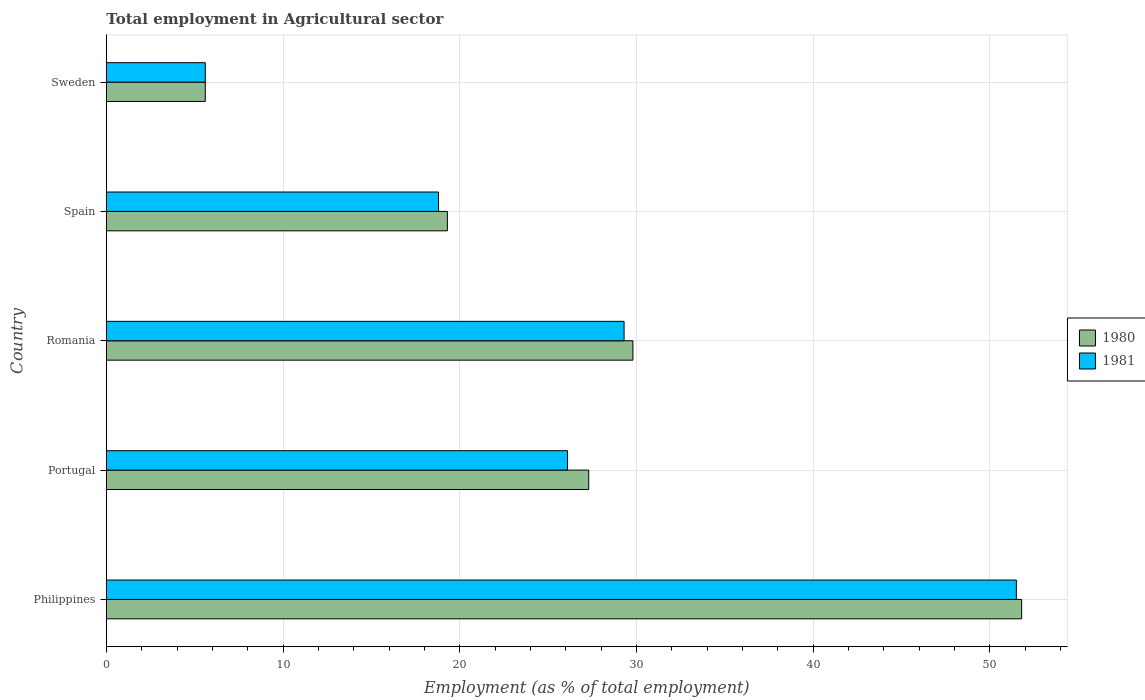How many groups of bars are there?
Give a very brief answer. 5. Are the number of bars on each tick of the Y-axis equal?
Offer a terse response. Yes. How many bars are there on the 3rd tick from the top?
Give a very brief answer. 2. What is the employment in agricultural sector in 1980 in Philippines?
Keep it short and to the point. 51.8. Across all countries, what is the maximum employment in agricultural sector in 1981?
Give a very brief answer. 51.5. Across all countries, what is the minimum employment in agricultural sector in 1981?
Ensure brevity in your answer.  5.6. In which country was the employment in agricultural sector in 1981 maximum?
Provide a succinct answer. Philippines. In which country was the employment in agricultural sector in 1980 minimum?
Your answer should be compact. Sweden. What is the total employment in agricultural sector in 1980 in the graph?
Offer a very short reply. 133.8. What is the difference between the employment in agricultural sector in 1981 in Philippines and that in Romania?
Make the answer very short. 22.2. What is the difference between the employment in agricultural sector in 1981 in Philippines and the employment in agricultural sector in 1980 in Romania?
Make the answer very short. 21.7. What is the average employment in agricultural sector in 1980 per country?
Provide a succinct answer. 26.76. What is the difference between the employment in agricultural sector in 1981 and employment in agricultural sector in 1980 in Sweden?
Your answer should be very brief. 0. What is the ratio of the employment in agricultural sector in 1981 in Portugal to that in Spain?
Your answer should be compact. 1.39. What is the difference between the highest and the second highest employment in agricultural sector in 1980?
Provide a succinct answer. 22. What is the difference between the highest and the lowest employment in agricultural sector in 1981?
Ensure brevity in your answer.  45.9. In how many countries, is the employment in agricultural sector in 1981 greater than the average employment in agricultural sector in 1981 taken over all countries?
Provide a short and direct response. 2. What does the 1st bar from the top in Portugal represents?
Ensure brevity in your answer.  1981. What does the 2nd bar from the bottom in Romania represents?
Provide a succinct answer. 1981. Are all the bars in the graph horizontal?
Your answer should be compact. Yes. What is the difference between two consecutive major ticks on the X-axis?
Your answer should be very brief. 10. Are the values on the major ticks of X-axis written in scientific E-notation?
Provide a short and direct response. No. Does the graph contain any zero values?
Offer a terse response. No. Where does the legend appear in the graph?
Offer a very short reply. Center right. How are the legend labels stacked?
Ensure brevity in your answer.  Vertical. What is the title of the graph?
Ensure brevity in your answer.  Total employment in Agricultural sector. What is the label or title of the X-axis?
Your answer should be very brief. Employment (as % of total employment). What is the Employment (as % of total employment) of 1980 in Philippines?
Your response must be concise. 51.8. What is the Employment (as % of total employment) in 1981 in Philippines?
Your answer should be very brief. 51.5. What is the Employment (as % of total employment) of 1980 in Portugal?
Your answer should be compact. 27.3. What is the Employment (as % of total employment) of 1981 in Portugal?
Provide a succinct answer. 26.1. What is the Employment (as % of total employment) in 1980 in Romania?
Your response must be concise. 29.8. What is the Employment (as % of total employment) of 1981 in Romania?
Offer a very short reply. 29.3. What is the Employment (as % of total employment) of 1980 in Spain?
Keep it short and to the point. 19.3. What is the Employment (as % of total employment) in 1981 in Spain?
Offer a very short reply. 18.8. What is the Employment (as % of total employment) of 1980 in Sweden?
Give a very brief answer. 5.6. What is the Employment (as % of total employment) in 1981 in Sweden?
Provide a short and direct response. 5.6. Across all countries, what is the maximum Employment (as % of total employment) of 1980?
Your response must be concise. 51.8. Across all countries, what is the maximum Employment (as % of total employment) of 1981?
Provide a succinct answer. 51.5. Across all countries, what is the minimum Employment (as % of total employment) of 1980?
Make the answer very short. 5.6. Across all countries, what is the minimum Employment (as % of total employment) of 1981?
Your answer should be very brief. 5.6. What is the total Employment (as % of total employment) of 1980 in the graph?
Give a very brief answer. 133.8. What is the total Employment (as % of total employment) of 1981 in the graph?
Offer a very short reply. 131.3. What is the difference between the Employment (as % of total employment) of 1980 in Philippines and that in Portugal?
Your response must be concise. 24.5. What is the difference between the Employment (as % of total employment) in 1981 in Philippines and that in Portugal?
Your answer should be very brief. 25.4. What is the difference between the Employment (as % of total employment) of 1980 in Philippines and that in Romania?
Your response must be concise. 22. What is the difference between the Employment (as % of total employment) in 1981 in Philippines and that in Romania?
Ensure brevity in your answer.  22.2. What is the difference between the Employment (as % of total employment) in 1980 in Philippines and that in Spain?
Make the answer very short. 32.5. What is the difference between the Employment (as % of total employment) of 1981 in Philippines and that in Spain?
Offer a very short reply. 32.7. What is the difference between the Employment (as % of total employment) of 1980 in Philippines and that in Sweden?
Provide a succinct answer. 46.2. What is the difference between the Employment (as % of total employment) of 1981 in Philippines and that in Sweden?
Provide a short and direct response. 45.9. What is the difference between the Employment (as % of total employment) in 1981 in Portugal and that in Romania?
Offer a very short reply. -3.2. What is the difference between the Employment (as % of total employment) in 1980 in Portugal and that in Sweden?
Keep it short and to the point. 21.7. What is the difference between the Employment (as % of total employment) of 1981 in Portugal and that in Sweden?
Ensure brevity in your answer.  20.5. What is the difference between the Employment (as % of total employment) of 1980 in Romania and that in Spain?
Your answer should be compact. 10.5. What is the difference between the Employment (as % of total employment) in 1981 in Romania and that in Spain?
Give a very brief answer. 10.5. What is the difference between the Employment (as % of total employment) in 1980 in Romania and that in Sweden?
Offer a very short reply. 24.2. What is the difference between the Employment (as % of total employment) in 1981 in Romania and that in Sweden?
Give a very brief answer. 23.7. What is the difference between the Employment (as % of total employment) of 1980 in Philippines and the Employment (as % of total employment) of 1981 in Portugal?
Keep it short and to the point. 25.7. What is the difference between the Employment (as % of total employment) in 1980 in Philippines and the Employment (as % of total employment) in 1981 in Spain?
Your response must be concise. 33. What is the difference between the Employment (as % of total employment) of 1980 in Philippines and the Employment (as % of total employment) of 1981 in Sweden?
Your answer should be very brief. 46.2. What is the difference between the Employment (as % of total employment) of 1980 in Portugal and the Employment (as % of total employment) of 1981 in Spain?
Your answer should be compact. 8.5. What is the difference between the Employment (as % of total employment) in 1980 in Portugal and the Employment (as % of total employment) in 1981 in Sweden?
Ensure brevity in your answer.  21.7. What is the difference between the Employment (as % of total employment) of 1980 in Romania and the Employment (as % of total employment) of 1981 in Sweden?
Ensure brevity in your answer.  24.2. What is the difference between the Employment (as % of total employment) in 1980 in Spain and the Employment (as % of total employment) in 1981 in Sweden?
Provide a succinct answer. 13.7. What is the average Employment (as % of total employment) in 1980 per country?
Offer a terse response. 26.76. What is the average Employment (as % of total employment) in 1981 per country?
Provide a short and direct response. 26.26. What is the difference between the Employment (as % of total employment) in 1980 and Employment (as % of total employment) in 1981 in Philippines?
Provide a short and direct response. 0.3. What is the difference between the Employment (as % of total employment) in 1980 and Employment (as % of total employment) in 1981 in Portugal?
Offer a very short reply. 1.2. What is the difference between the Employment (as % of total employment) in 1980 and Employment (as % of total employment) in 1981 in Romania?
Offer a terse response. 0.5. What is the difference between the Employment (as % of total employment) in 1980 and Employment (as % of total employment) in 1981 in Spain?
Your answer should be compact. 0.5. What is the ratio of the Employment (as % of total employment) of 1980 in Philippines to that in Portugal?
Your response must be concise. 1.9. What is the ratio of the Employment (as % of total employment) of 1981 in Philippines to that in Portugal?
Ensure brevity in your answer.  1.97. What is the ratio of the Employment (as % of total employment) of 1980 in Philippines to that in Romania?
Your answer should be compact. 1.74. What is the ratio of the Employment (as % of total employment) in 1981 in Philippines to that in Romania?
Keep it short and to the point. 1.76. What is the ratio of the Employment (as % of total employment) in 1980 in Philippines to that in Spain?
Your answer should be very brief. 2.68. What is the ratio of the Employment (as % of total employment) in 1981 in Philippines to that in Spain?
Offer a terse response. 2.74. What is the ratio of the Employment (as % of total employment) of 1980 in Philippines to that in Sweden?
Offer a very short reply. 9.25. What is the ratio of the Employment (as % of total employment) of 1981 in Philippines to that in Sweden?
Ensure brevity in your answer.  9.2. What is the ratio of the Employment (as % of total employment) in 1980 in Portugal to that in Romania?
Keep it short and to the point. 0.92. What is the ratio of the Employment (as % of total employment) of 1981 in Portugal to that in Romania?
Your answer should be compact. 0.89. What is the ratio of the Employment (as % of total employment) in 1980 in Portugal to that in Spain?
Offer a very short reply. 1.41. What is the ratio of the Employment (as % of total employment) in 1981 in Portugal to that in Spain?
Offer a terse response. 1.39. What is the ratio of the Employment (as % of total employment) in 1980 in Portugal to that in Sweden?
Offer a terse response. 4.88. What is the ratio of the Employment (as % of total employment) of 1981 in Portugal to that in Sweden?
Ensure brevity in your answer.  4.66. What is the ratio of the Employment (as % of total employment) in 1980 in Romania to that in Spain?
Give a very brief answer. 1.54. What is the ratio of the Employment (as % of total employment) of 1981 in Romania to that in Spain?
Your answer should be compact. 1.56. What is the ratio of the Employment (as % of total employment) of 1980 in Romania to that in Sweden?
Provide a succinct answer. 5.32. What is the ratio of the Employment (as % of total employment) of 1981 in Romania to that in Sweden?
Ensure brevity in your answer.  5.23. What is the ratio of the Employment (as % of total employment) of 1980 in Spain to that in Sweden?
Your answer should be compact. 3.45. What is the ratio of the Employment (as % of total employment) in 1981 in Spain to that in Sweden?
Your answer should be compact. 3.36. What is the difference between the highest and the second highest Employment (as % of total employment) of 1981?
Your response must be concise. 22.2. What is the difference between the highest and the lowest Employment (as % of total employment) in 1980?
Your answer should be very brief. 46.2. What is the difference between the highest and the lowest Employment (as % of total employment) of 1981?
Give a very brief answer. 45.9. 